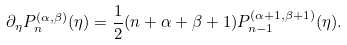<formula> <loc_0><loc_0><loc_500><loc_500>\partial _ { \eta } P _ { n } ^ { ( \alpha , \beta ) } ( \eta ) = \frac { 1 } { 2 } ( n + \alpha + \beta + 1 ) P _ { n - 1 } ^ { ( \alpha + 1 , \beta + 1 ) } ( \eta ) .</formula> 